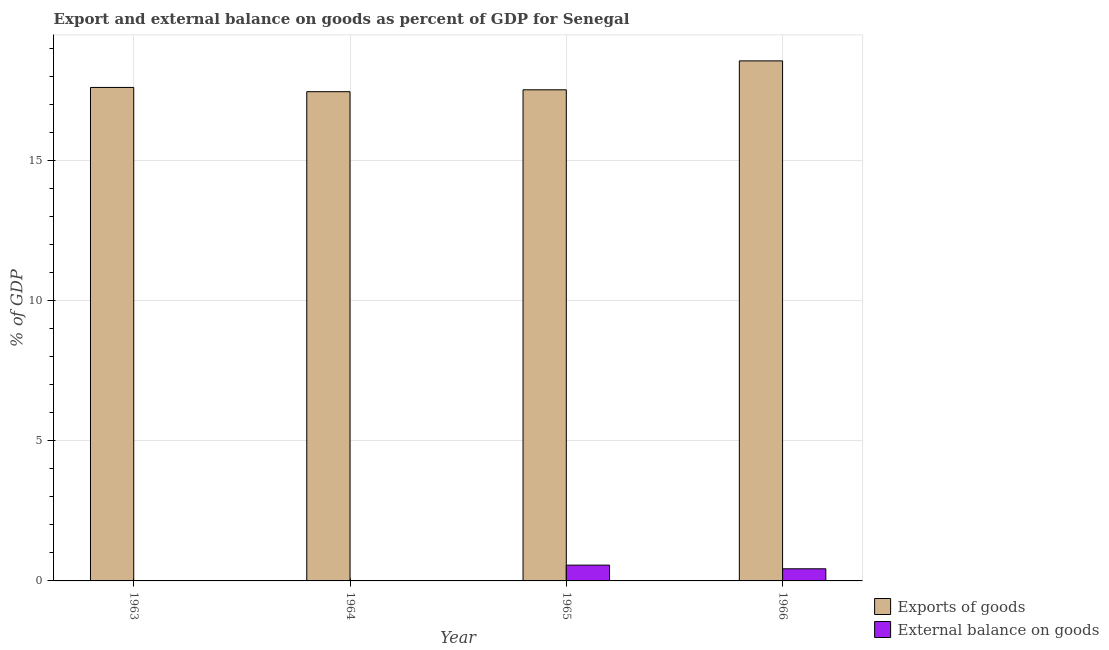How many different coloured bars are there?
Provide a succinct answer. 2. Are the number of bars per tick equal to the number of legend labels?
Offer a terse response. No. Are the number of bars on each tick of the X-axis equal?
Keep it short and to the point. No. What is the label of the 2nd group of bars from the left?
Keep it short and to the point. 1964. In how many cases, is the number of bars for a given year not equal to the number of legend labels?
Your answer should be very brief. 2. What is the export of goods as percentage of gdp in 1966?
Your response must be concise. 18.57. Across all years, what is the maximum external balance on goods as percentage of gdp?
Make the answer very short. 0.56. Across all years, what is the minimum external balance on goods as percentage of gdp?
Provide a short and direct response. 0. In which year was the external balance on goods as percentage of gdp maximum?
Provide a short and direct response. 1965. What is the total external balance on goods as percentage of gdp in the graph?
Offer a terse response. 1. What is the difference between the export of goods as percentage of gdp in 1963 and that in 1964?
Your answer should be very brief. 0.15. What is the average export of goods as percentage of gdp per year?
Your response must be concise. 17.8. In the year 1965, what is the difference between the external balance on goods as percentage of gdp and export of goods as percentage of gdp?
Make the answer very short. 0. What is the ratio of the export of goods as percentage of gdp in 1964 to that in 1966?
Your answer should be very brief. 0.94. Is the export of goods as percentage of gdp in 1963 less than that in 1964?
Ensure brevity in your answer.  No. What is the difference between the highest and the second highest export of goods as percentage of gdp?
Your response must be concise. 0.95. What is the difference between the highest and the lowest export of goods as percentage of gdp?
Your response must be concise. 1.1. Is the sum of the export of goods as percentage of gdp in 1965 and 1966 greater than the maximum external balance on goods as percentage of gdp across all years?
Provide a short and direct response. Yes. How many bars are there?
Provide a short and direct response. 6. Are all the bars in the graph horizontal?
Keep it short and to the point. No. Does the graph contain grids?
Your answer should be very brief. Yes. How are the legend labels stacked?
Your answer should be very brief. Vertical. What is the title of the graph?
Make the answer very short. Export and external balance on goods as percent of GDP for Senegal. Does "Male population" appear as one of the legend labels in the graph?
Offer a terse response. No. What is the label or title of the Y-axis?
Provide a succinct answer. % of GDP. What is the % of GDP of Exports of goods in 1963?
Offer a very short reply. 17.62. What is the % of GDP of External balance on goods in 1963?
Your answer should be very brief. 0. What is the % of GDP in Exports of goods in 1964?
Provide a short and direct response. 17.47. What is the % of GDP of Exports of goods in 1965?
Your response must be concise. 17.53. What is the % of GDP in External balance on goods in 1965?
Ensure brevity in your answer.  0.56. What is the % of GDP of Exports of goods in 1966?
Ensure brevity in your answer.  18.57. What is the % of GDP of External balance on goods in 1966?
Provide a short and direct response. 0.43. Across all years, what is the maximum % of GDP in Exports of goods?
Your answer should be compact. 18.57. Across all years, what is the maximum % of GDP in External balance on goods?
Provide a succinct answer. 0.56. Across all years, what is the minimum % of GDP in Exports of goods?
Keep it short and to the point. 17.47. What is the total % of GDP in Exports of goods in the graph?
Make the answer very short. 71.18. What is the total % of GDP in External balance on goods in the graph?
Ensure brevity in your answer.  1. What is the difference between the % of GDP of Exports of goods in 1963 and that in 1964?
Offer a terse response. 0.15. What is the difference between the % of GDP of Exports of goods in 1963 and that in 1965?
Offer a terse response. 0.08. What is the difference between the % of GDP in Exports of goods in 1963 and that in 1966?
Keep it short and to the point. -0.95. What is the difference between the % of GDP in Exports of goods in 1964 and that in 1965?
Your response must be concise. -0.07. What is the difference between the % of GDP of Exports of goods in 1964 and that in 1966?
Offer a very short reply. -1.1. What is the difference between the % of GDP of Exports of goods in 1965 and that in 1966?
Your answer should be compact. -1.03. What is the difference between the % of GDP in External balance on goods in 1965 and that in 1966?
Offer a terse response. 0.13. What is the difference between the % of GDP in Exports of goods in 1963 and the % of GDP in External balance on goods in 1965?
Provide a succinct answer. 17.05. What is the difference between the % of GDP of Exports of goods in 1963 and the % of GDP of External balance on goods in 1966?
Provide a succinct answer. 17.18. What is the difference between the % of GDP in Exports of goods in 1964 and the % of GDP in External balance on goods in 1965?
Your response must be concise. 16.9. What is the difference between the % of GDP of Exports of goods in 1964 and the % of GDP of External balance on goods in 1966?
Keep it short and to the point. 17.03. What is the difference between the % of GDP of Exports of goods in 1965 and the % of GDP of External balance on goods in 1966?
Provide a short and direct response. 17.1. What is the average % of GDP in Exports of goods per year?
Offer a very short reply. 17.8. What is the average % of GDP of External balance on goods per year?
Make the answer very short. 0.25. In the year 1965, what is the difference between the % of GDP of Exports of goods and % of GDP of External balance on goods?
Offer a very short reply. 16.97. In the year 1966, what is the difference between the % of GDP of Exports of goods and % of GDP of External balance on goods?
Provide a succinct answer. 18.13. What is the ratio of the % of GDP in Exports of goods in 1963 to that in 1964?
Ensure brevity in your answer.  1.01. What is the ratio of the % of GDP of Exports of goods in 1963 to that in 1966?
Your answer should be very brief. 0.95. What is the ratio of the % of GDP in Exports of goods in 1964 to that in 1965?
Ensure brevity in your answer.  1. What is the ratio of the % of GDP in Exports of goods in 1964 to that in 1966?
Provide a short and direct response. 0.94. What is the ratio of the % of GDP of Exports of goods in 1965 to that in 1966?
Your answer should be compact. 0.94. What is the ratio of the % of GDP of External balance on goods in 1965 to that in 1966?
Your answer should be compact. 1.3. What is the difference between the highest and the second highest % of GDP of Exports of goods?
Keep it short and to the point. 0.95. What is the difference between the highest and the lowest % of GDP in Exports of goods?
Give a very brief answer. 1.1. What is the difference between the highest and the lowest % of GDP in External balance on goods?
Offer a very short reply. 0.56. 